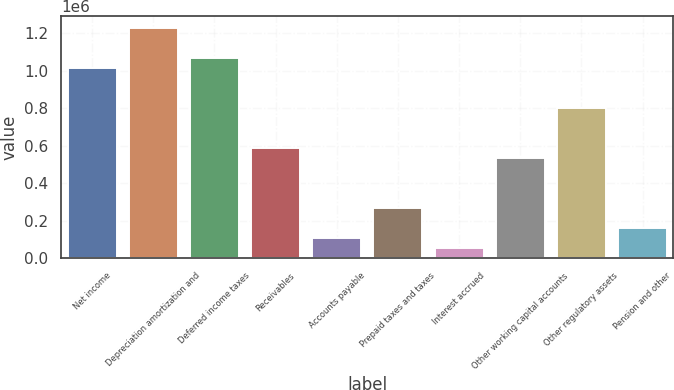Convert chart to OTSL. <chart><loc_0><loc_0><loc_500><loc_500><bar_chart><fcel>Net income<fcel>Depreciation amortization and<fcel>Deferred income taxes<fcel>Receivables<fcel>Accounts payable<fcel>Prepaid taxes and taxes<fcel>Interest accrued<fcel>Other working capital accounts<fcel>Other regulatory assets<fcel>Pension and other<nl><fcel>1.01473e+06<fcel>1.22836e+06<fcel>1.06814e+06<fcel>587489<fcel>106837<fcel>267054<fcel>53431.7<fcel>534083<fcel>801112<fcel>160243<nl></chart> 